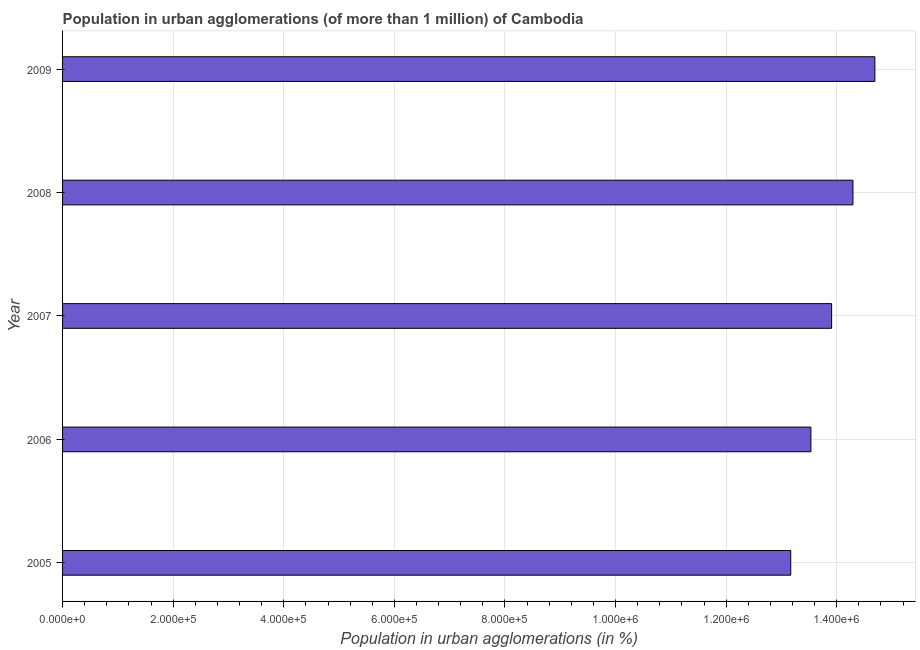Does the graph contain any zero values?
Give a very brief answer. No. Does the graph contain grids?
Keep it short and to the point. Yes. What is the title of the graph?
Ensure brevity in your answer.  Population in urban agglomerations (of more than 1 million) of Cambodia. What is the label or title of the X-axis?
Keep it short and to the point. Population in urban agglomerations (in %). What is the label or title of the Y-axis?
Give a very brief answer. Year. What is the population in urban agglomerations in 2008?
Give a very brief answer. 1.43e+06. Across all years, what is the maximum population in urban agglomerations?
Give a very brief answer. 1.47e+06. Across all years, what is the minimum population in urban agglomerations?
Offer a terse response. 1.32e+06. In which year was the population in urban agglomerations maximum?
Offer a very short reply. 2009. In which year was the population in urban agglomerations minimum?
Keep it short and to the point. 2005. What is the sum of the population in urban agglomerations?
Ensure brevity in your answer.  6.96e+06. What is the difference between the population in urban agglomerations in 2007 and 2009?
Keep it short and to the point. -7.82e+04. What is the average population in urban agglomerations per year?
Give a very brief answer. 1.39e+06. What is the median population in urban agglomerations?
Keep it short and to the point. 1.39e+06. Do a majority of the years between 2009 and 2006 (inclusive) have population in urban agglomerations greater than 760000 %?
Your answer should be very brief. Yes. What is the ratio of the population in urban agglomerations in 2006 to that in 2007?
Provide a short and direct response. 0.97. Is the difference between the population in urban agglomerations in 2008 and 2009 greater than the difference between any two years?
Your answer should be compact. No. What is the difference between the highest and the second highest population in urban agglomerations?
Offer a terse response. 3.96e+04. What is the difference between the highest and the lowest population in urban agglomerations?
Offer a very short reply. 1.52e+05. In how many years, is the population in urban agglomerations greater than the average population in urban agglomerations taken over all years?
Make the answer very short. 2. Are all the bars in the graph horizontal?
Your answer should be compact. Yes. How many years are there in the graph?
Ensure brevity in your answer.  5. What is the difference between two consecutive major ticks on the X-axis?
Offer a terse response. 2.00e+05. What is the Population in urban agglomerations (in %) in 2005?
Your answer should be compact. 1.32e+06. What is the Population in urban agglomerations (in %) of 2006?
Make the answer very short. 1.35e+06. What is the Population in urban agglomerations (in %) in 2007?
Offer a terse response. 1.39e+06. What is the Population in urban agglomerations (in %) of 2008?
Offer a terse response. 1.43e+06. What is the Population in urban agglomerations (in %) in 2009?
Ensure brevity in your answer.  1.47e+06. What is the difference between the Population in urban agglomerations (in %) in 2005 and 2006?
Ensure brevity in your answer.  -3.65e+04. What is the difference between the Population in urban agglomerations (in %) in 2005 and 2007?
Your answer should be compact. -7.40e+04. What is the difference between the Population in urban agglomerations (in %) in 2005 and 2008?
Your answer should be compact. -1.13e+05. What is the difference between the Population in urban agglomerations (in %) in 2005 and 2009?
Give a very brief answer. -1.52e+05. What is the difference between the Population in urban agglomerations (in %) in 2006 and 2007?
Offer a terse response. -3.75e+04. What is the difference between the Population in urban agglomerations (in %) in 2006 and 2008?
Your response must be concise. -7.61e+04. What is the difference between the Population in urban agglomerations (in %) in 2006 and 2009?
Provide a succinct answer. -1.16e+05. What is the difference between the Population in urban agglomerations (in %) in 2007 and 2008?
Offer a terse response. -3.86e+04. What is the difference between the Population in urban agglomerations (in %) in 2007 and 2009?
Provide a short and direct response. -7.82e+04. What is the difference between the Population in urban agglomerations (in %) in 2008 and 2009?
Your answer should be compact. -3.96e+04. What is the ratio of the Population in urban agglomerations (in %) in 2005 to that in 2006?
Offer a terse response. 0.97. What is the ratio of the Population in urban agglomerations (in %) in 2005 to that in 2007?
Your answer should be compact. 0.95. What is the ratio of the Population in urban agglomerations (in %) in 2005 to that in 2008?
Offer a terse response. 0.92. What is the ratio of the Population in urban agglomerations (in %) in 2005 to that in 2009?
Offer a terse response. 0.9. What is the ratio of the Population in urban agglomerations (in %) in 2006 to that in 2008?
Give a very brief answer. 0.95. What is the ratio of the Population in urban agglomerations (in %) in 2006 to that in 2009?
Give a very brief answer. 0.92. What is the ratio of the Population in urban agglomerations (in %) in 2007 to that in 2009?
Your response must be concise. 0.95. What is the ratio of the Population in urban agglomerations (in %) in 2008 to that in 2009?
Offer a terse response. 0.97. 